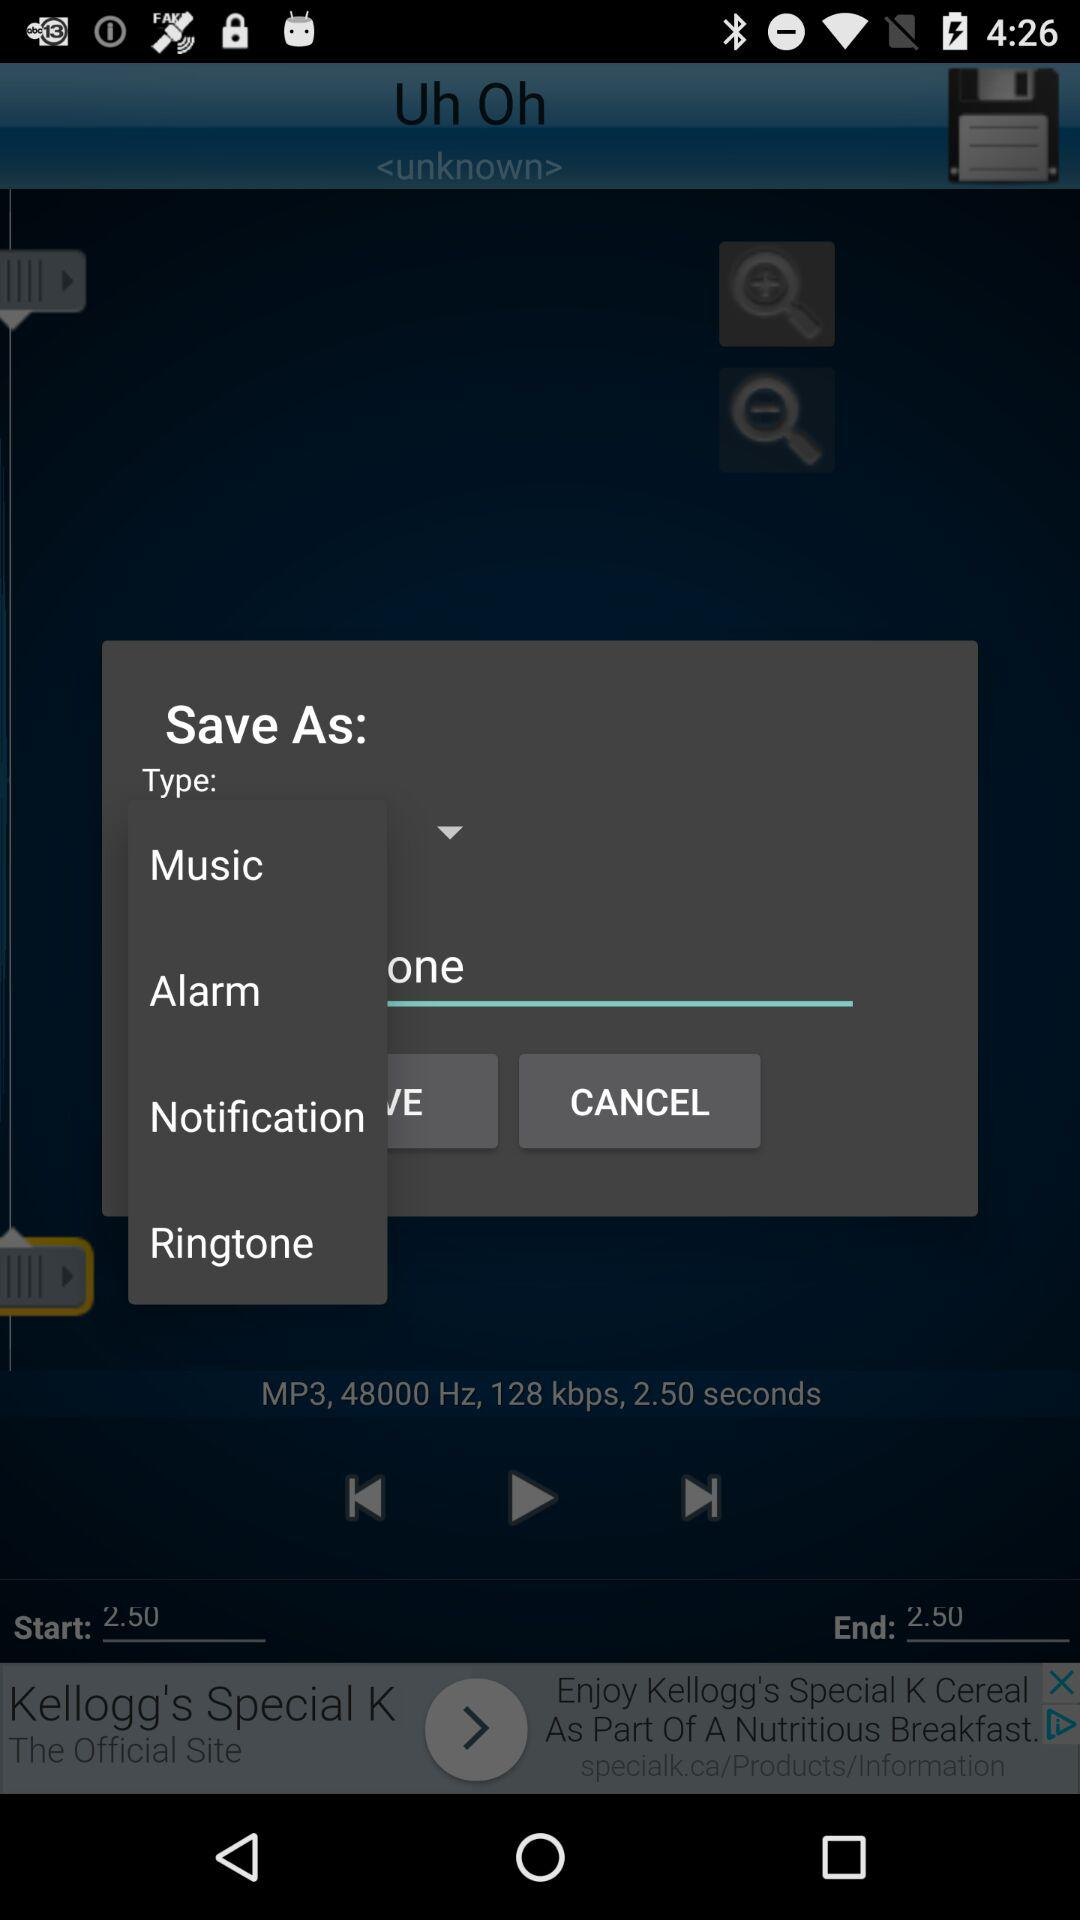What is the start time of the song?
When the provided information is insufficient, respond with <no answer>. <no answer> 